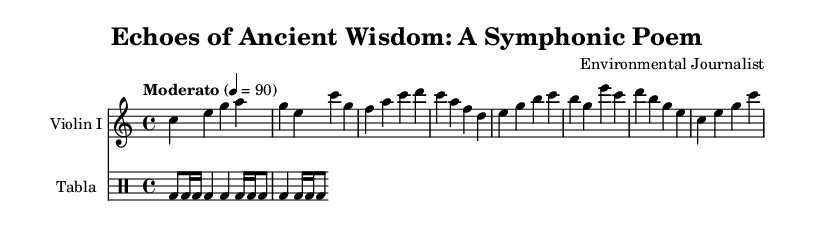What is the key signature of this music? The key signature is indicated at the beginning of the score, showing no sharps or flats, which corresponds to C major.
Answer: C major What is the time signature of this piece? The time signature is located at the beginning of the score, displaying "4/4", meaning there are four beats in each measure, with the quarter note getting one beat.
Answer: 4/4 What is the tempo marking for this symphony? The tempo marking is stated as "Moderato," which is a term indicating a moderate pace, followed by "4 = 90," suggesting the metronome marking for the beats per minute.
Answer: Moderato How many measures are there in the Violin I part? By counting the distinct groups of notes separated by the vertical lines, there are eight measures in the Violin I part.
Answer: 8 What instrument is playing the rhythmic accompaniment? The rhythmic accompaniment is indicated by the presence of a drum staff specifically labeled for the tabla, which is a traditional Indian percussion instrument.
Answer: Tabla Which note appears most frequently in the Violin I part? By analyzing the notes written in the Violin I part, the note 'c' appears the most often throughout the measures.
Answer: C How is the cultural theme of urban planning represented in the symphonic poem? While sheet music itself does not convey cultural themes, the title "Echoes of Ancient Wisdom" suggests that the music honors sustainable practices from ancient Indian cities, embodied through the combination of traditional instruments like the tabla and thematic melodies.
Answer: Ancient Indian cities 